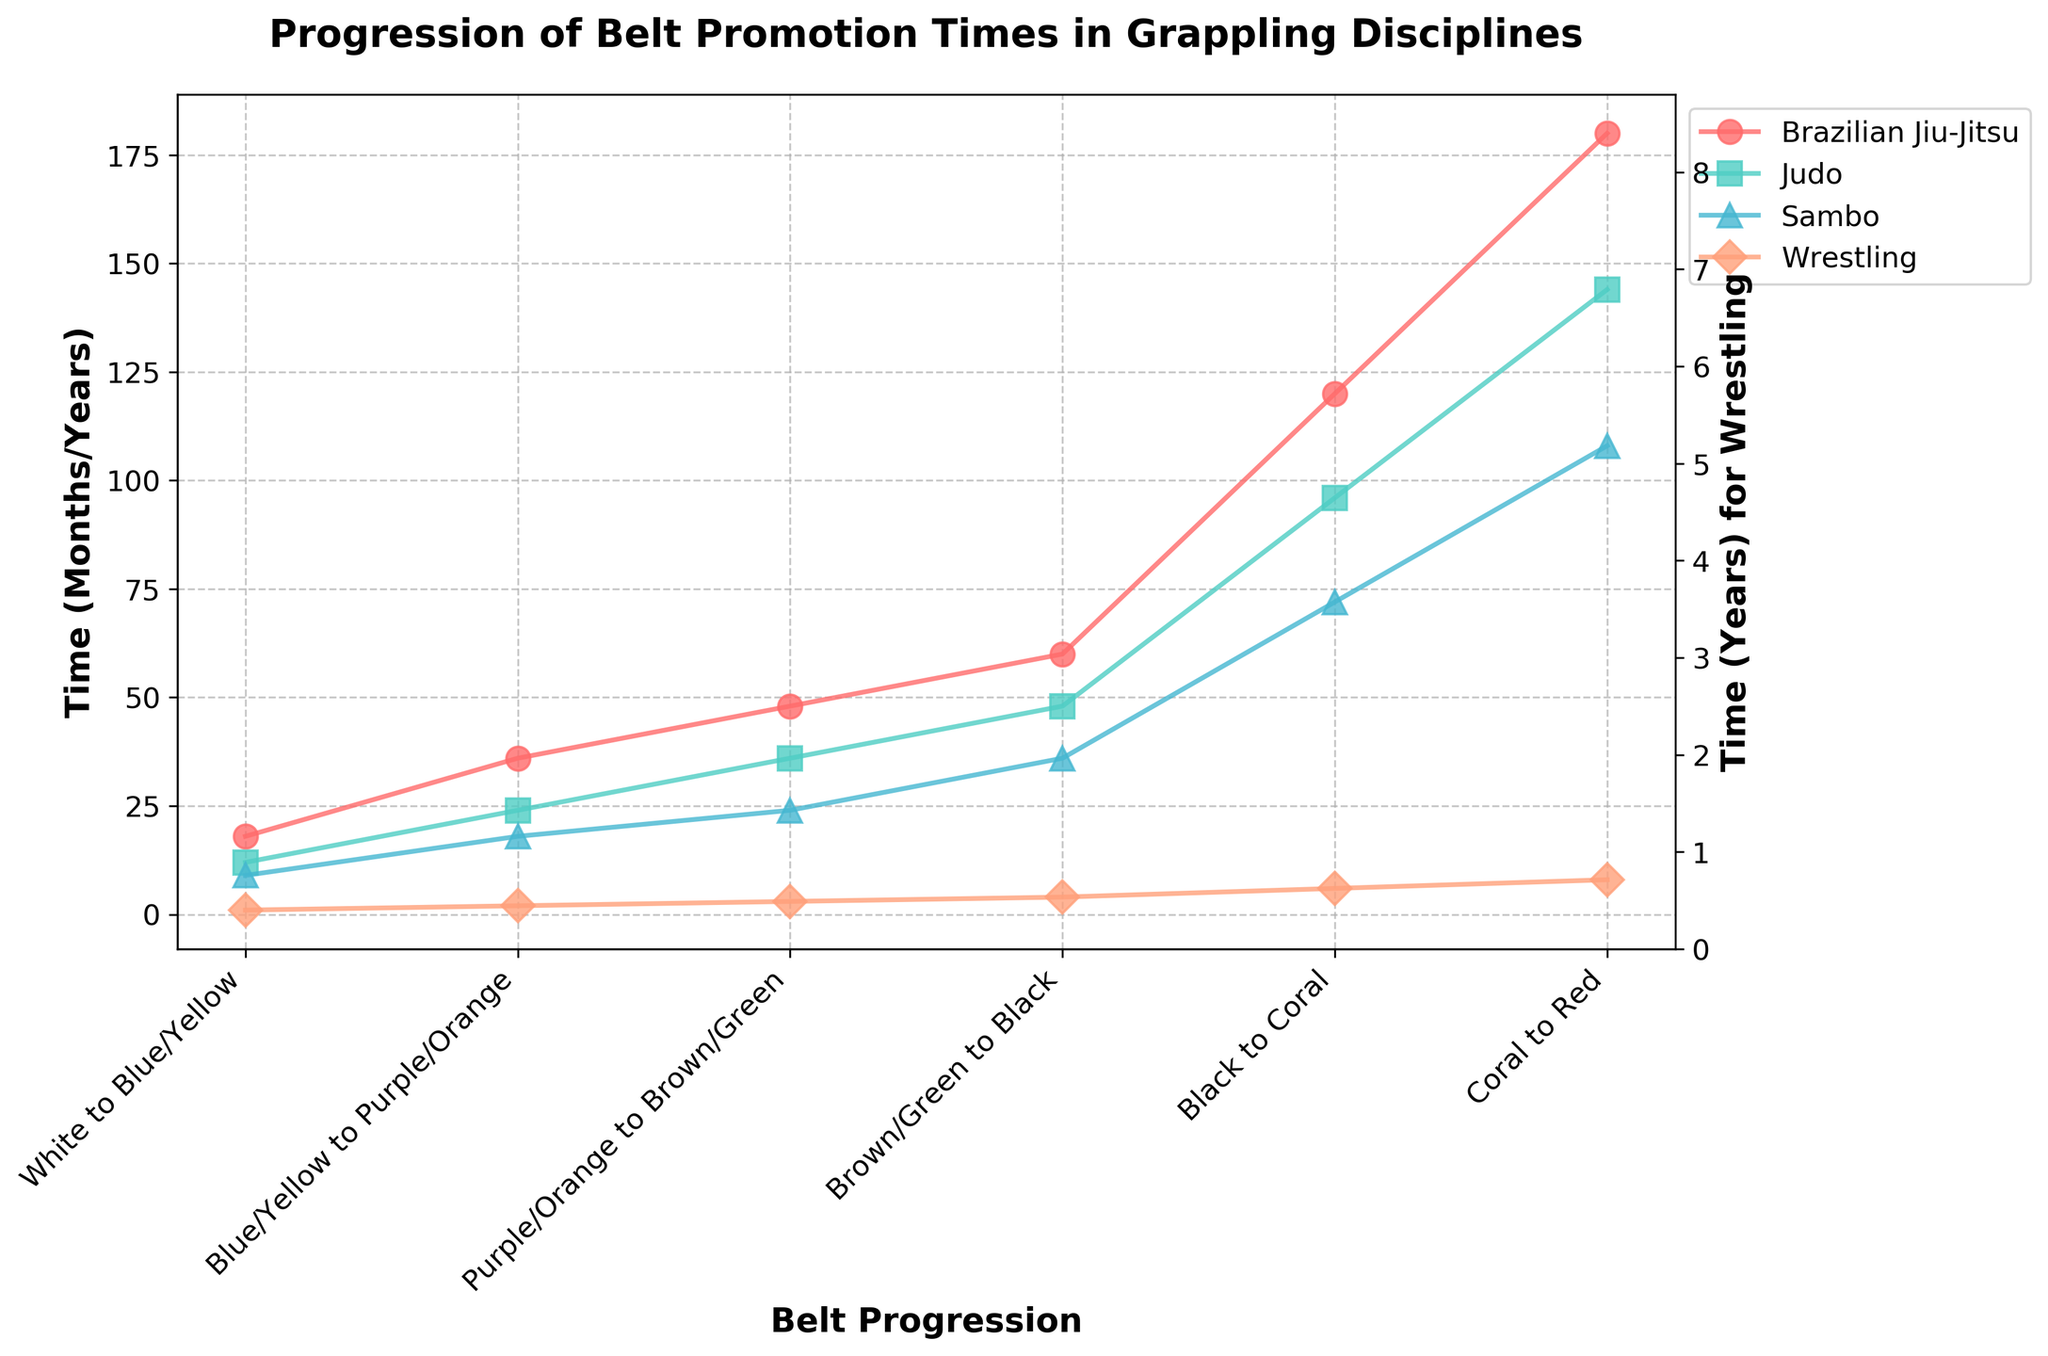What is the average promotion time from Brown/Green to Black across all disciplines in months? To find the average promotion time from Brown/Green to Black, we first convert the Wrestling time in years to months (4 years * 12 months/year = 48 months). Then average the values: (60 + 48 + 36 + 48) / 4 = 192 / 4 = 48
Answer: 48 months Which discipline takes the shortest time to achieve a Black belt from White? Look at the time it takes for each belt promotion and sum them up for each discipline. Judo has the shortest total: 12 + 24 + 36 + 48 = 120 months.
Answer: Judo How long does it take to progress from Black to Coral in Brazilian Jiu-Jitsu compared to Sambo? Brazilian Jiu-Jitsu takes 120 months, and Sambo takes 72 months. Compare the two values, finding that Brazilian Jiu-Jitsu takes longer.
Answer: Brazilian Jiu-Jitsu takes longer Is the promotion time consistent across disciplines from Blue/Yellow to Purple/Orange? Compare the time it takes for each discipline from Blue/Yellow to Purple/Orange: Brazilian Jiu-Jitsu (36 months), Judo (24 months), Sambo (18 months), Wrestling (2 years or 24 months). It is not consistent.
Answer: No What is the total time in years to reach the Coral belt in Wrestling? First, add the times to reach each belt: 1 + 2 + 3 + 4 + 6. The total time is 16 years.
Answer: 16 years Which belt promotion interval shows the greatest difference between Brazilian Jiu-Jitsu and Judo? Calculate the differences for each interval: White-Blue/Yellow (6 months), Blue/Yellow-Purple/Orange (12 months), Purple/Orange-Brown/Green (12 months), Brown/Green-Black (12 months), Black-Coral (24 months), Coral-Red (36 months). The greatest difference is 36 months in the Coral to Red interval.
Answer: Coral to Red Which discipline spends the least amount of time between Coral and Red belts? View the times for Coral to Red: Brazilian Jiu-Jitsu (180 months), Judo (144 months), Sambo (108 months), Wrestling (8 years or 96 months). Wrestling spends the least amount of time.
Answer: Wrestling Compare the total time taken by Judo and Sambo to progress from White to Black. Who progresses faster? Sum the times: Judo (12 + 24 + 36 + 48 = 120 months), Sambo (9 + 18 + 24 + 36 = 87 months). Sambo progresses faster.
Answer: Sambo Between which two belts does Wrestling have the largest percentage increase in promotion time? Calculate the percentage increase for each transition: ((2 - 1) / 1) * 100% = 100%, ((3 - 2) / 2) * 100% = 50%, ((4 - 3) / 3) * 100% = 33.3%, ((6 - 4) / 4) * 100% = 50%. The largest increase is between White to Blue/Yellow (100%).
Answer: White to Blue/Yellow What is the ratio of time taken to achieve a Purple/Orange belt in Brazilian Jiu-Jitsu to that in Sambo? The time taken in Brazilian Jiu-Jitsu is 36 months, and in Sambo is 18 months. The ratio is 36 / 18 = 2:1
Answer: 2:1 